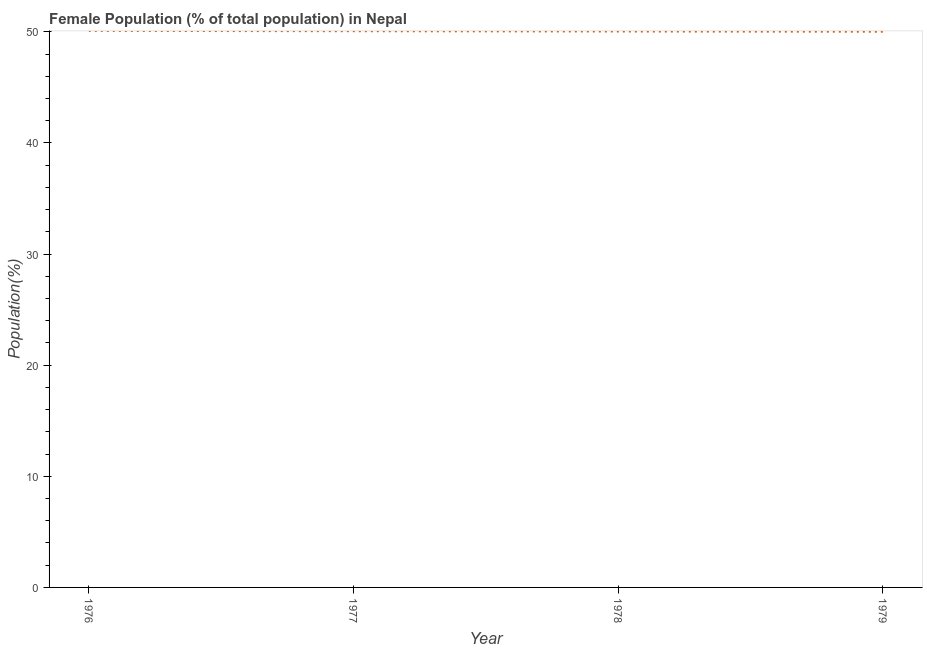What is the female population in 1977?
Offer a terse response. 50.05. Across all years, what is the maximum female population?
Give a very brief answer. 50.08. Across all years, what is the minimum female population?
Offer a very short reply. 50. In which year was the female population maximum?
Make the answer very short. 1976. In which year was the female population minimum?
Provide a succinct answer. 1979. What is the sum of the female population?
Your response must be concise. 200.16. What is the difference between the female population in 1978 and 1979?
Keep it short and to the point. 0.02. What is the average female population per year?
Offer a terse response. 50.04. What is the median female population?
Make the answer very short. 50.04. In how many years, is the female population greater than 4 %?
Your answer should be compact. 4. What is the ratio of the female population in 1977 to that in 1979?
Ensure brevity in your answer.  1. Is the female population in 1976 less than that in 1979?
Make the answer very short. No. Is the difference between the female population in 1978 and 1979 greater than the difference between any two years?
Your response must be concise. No. What is the difference between the highest and the second highest female population?
Offer a very short reply. 0.03. Is the sum of the female population in 1977 and 1978 greater than the maximum female population across all years?
Keep it short and to the point. Yes. What is the difference between the highest and the lowest female population?
Ensure brevity in your answer.  0.08. Does the female population monotonically increase over the years?
Your response must be concise. No. How many years are there in the graph?
Provide a short and direct response. 4. What is the difference between two consecutive major ticks on the Y-axis?
Your answer should be very brief. 10. Does the graph contain any zero values?
Provide a short and direct response. No. What is the title of the graph?
Offer a very short reply. Female Population (% of total population) in Nepal. What is the label or title of the X-axis?
Offer a very short reply. Year. What is the label or title of the Y-axis?
Your answer should be compact. Population(%). What is the Population(%) in 1976?
Ensure brevity in your answer.  50.08. What is the Population(%) of 1977?
Make the answer very short. 50.05. What is the Population(%) of 1978?
Offer a very short reply. 50.02. What is the Population(%) in 1979?
Provide a succinct answer. 50. What is the difference between the Population(%) in 1976 and 1977?
Give a very brief answer. 0.03. What is the difference between the Population(%) in 1976 and 1978?
Keep it short and to the point. 0.06. What is the difference between the Population(%) in 1976 and 1979?
Give a very brief answer. 0.08. What is the difference between the Population(%) in 1977 and 1978?
Provide a succinct answer. 0.03. What is the difference between the Population(%) in 1977 and 1979?
Your answer should be very brief. 0.05. What is the difference between the Population(%) in 1978 and 1979?
Ensure brevity in your answer.  0.02. What is the ratio of the Population(%) in 1976 to that in 1978?
Your answer should be compact. 1. What is the ratio of the Population(%) in 1976 to that in 1979?
Your response must be concise. 1. What is the ratio of the Population(%) in 1977 to that in 1978?
Your answer should be compact. 1. What is the ratio of the Population(%) in 1977 to that in 1979?
Provide a short and direct response. 1. 